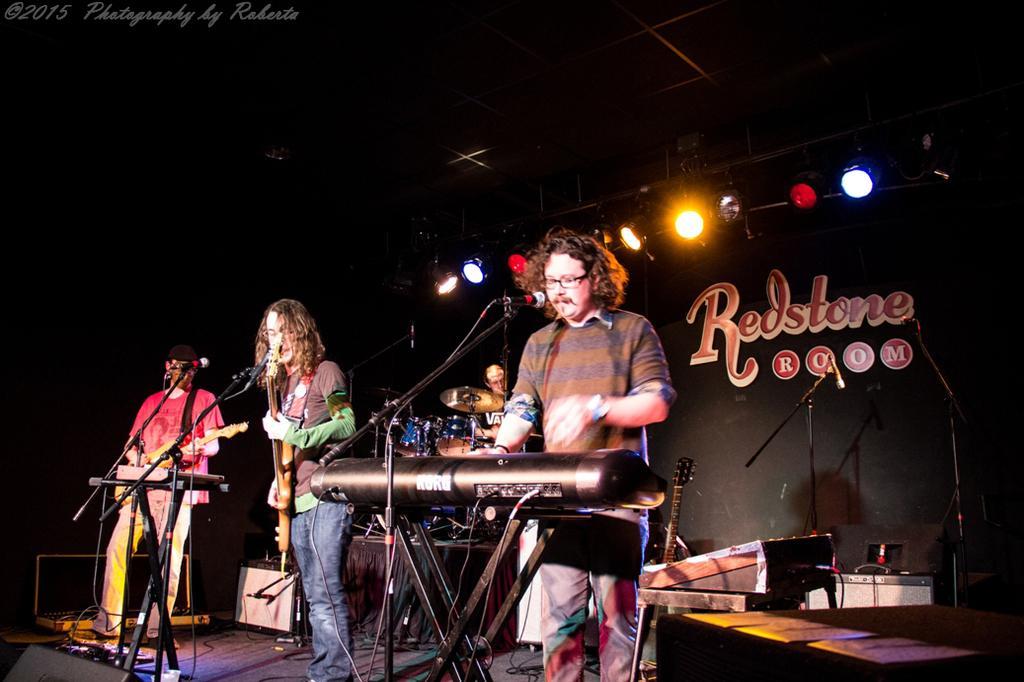Please provide a concise description of this image. These three persons are standing and playing musical instruments,There are microphone with stands. On the background there is a person playing musical instrument,wall,focusing lights. We can see guitar,electrical device,cables on the stage. 